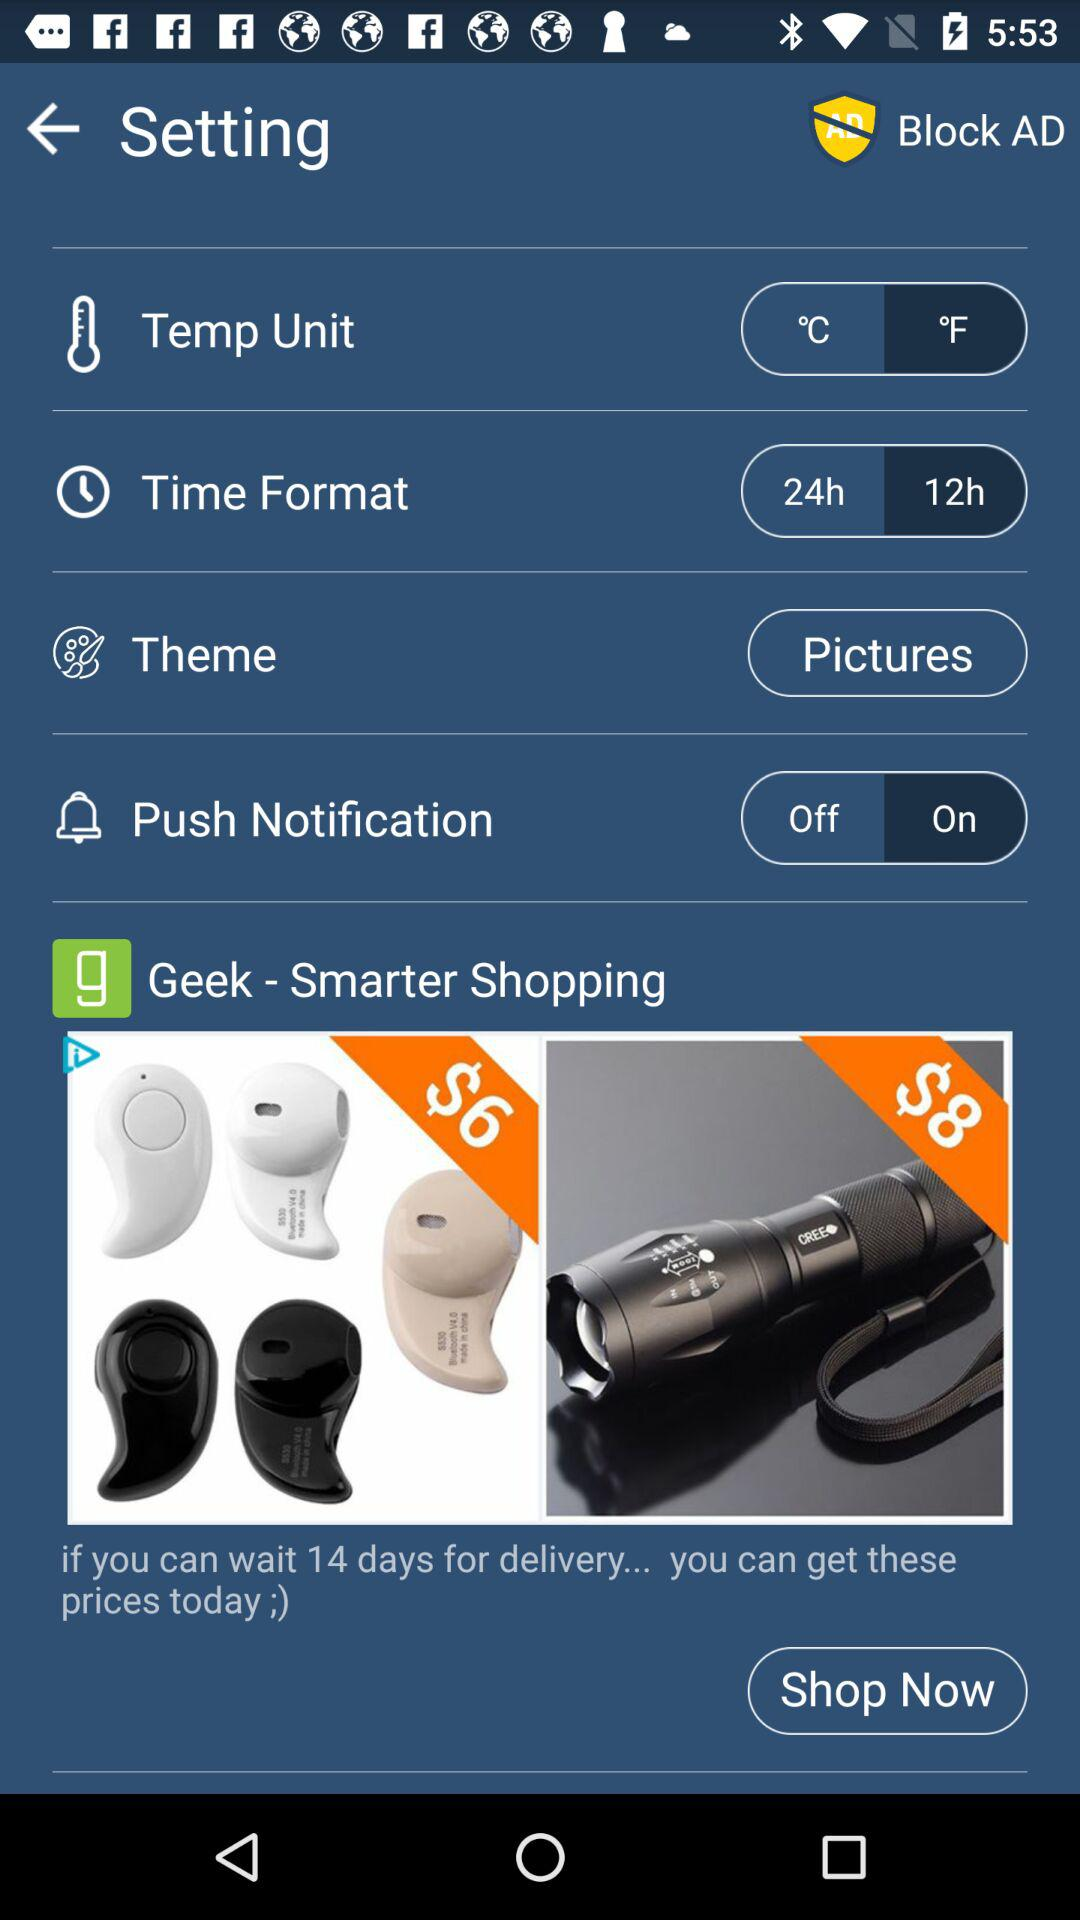How many items are available for purchase?
Answer the question using a single word or phrase. 2 